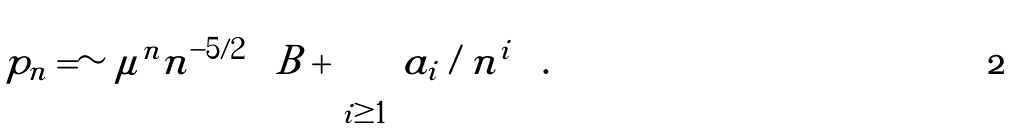Convert formula to latex. <formula><loc_0><loc_0><loc_500><loc_500>p _ { n } = \sim \mu ^ { n } n ^ { - 5 / 2 } \left [ B + \sum _ { i \geq 1 } a _ { i } / n ^ { i } \right ] .</formula> 